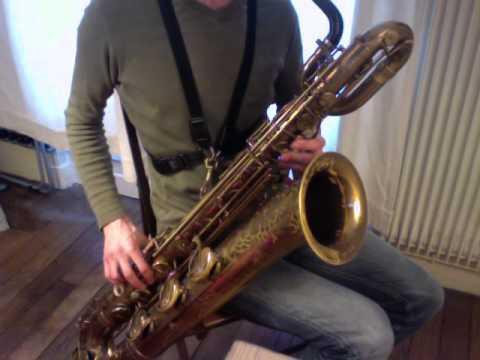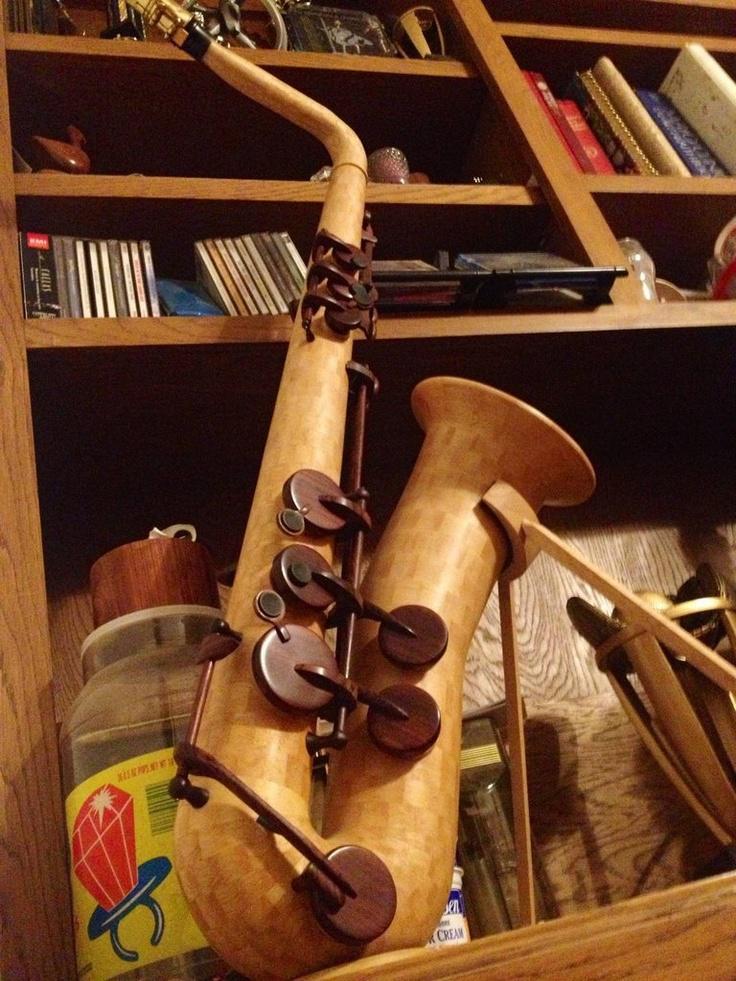The first image is the image on the left, the second image is the image on the right. Given the left and right images, does the statement "The image on the right contains a single saxophone on a white background." hold true? Answer yes or no. No. The first image is the image on the left, the second image is the image on the right. Assess this claim about the two images: "At least one image has no background.". Correct or not? Answer yes or no. No. The first image is the image on the left, the second image is the image on the right. Evaluate the accuracy of this statement regarding the images: "The right image features one wooden instrument on a white background.". Is it true? Answer yes or no. No. 